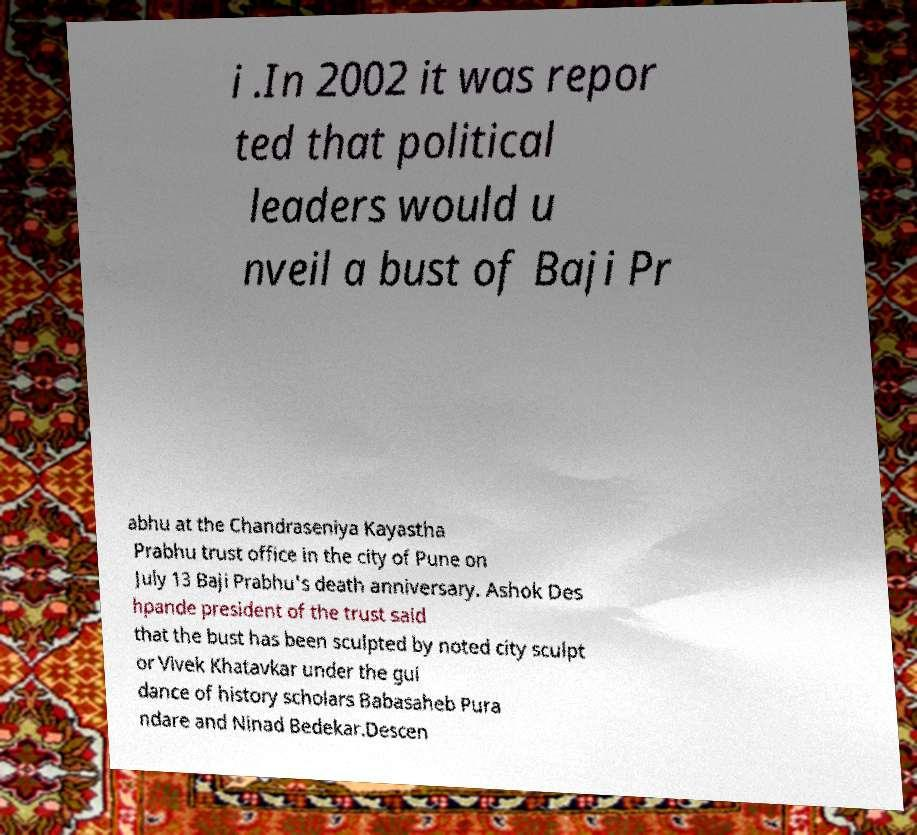I need the written content from this picture converted into text. Can you do that? i .In 2002 it was repor ted that political leaders would u nveil a bust of Baji Pr abhu at the Chandraseniya Kayastha Prabhu trust office in the city of Pune on July 13 Baji Prabhu's death anniversary. Ashok Des hpande president of the trust said that the bust has been sculpted by noted city sculpt or Vivek Khatavkar under the gui dance of history scholars Babasaheb Pura ndare and Ninad Bedekar.Descen 